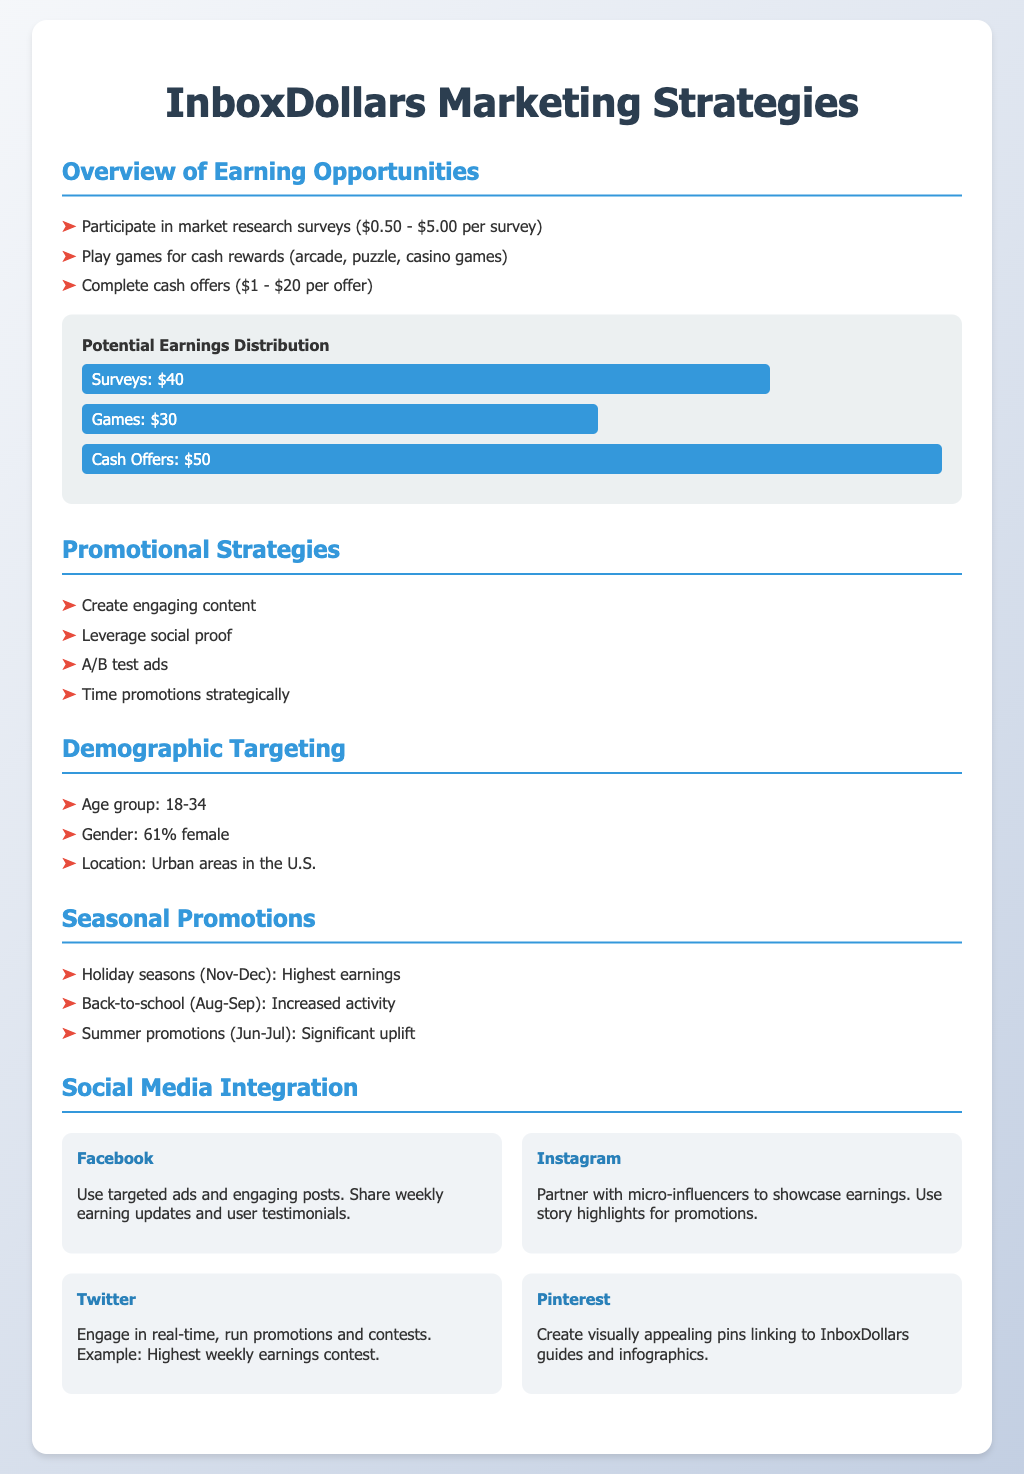What are the cash offers earnings range? The document states that earnings from cash offers range from $1 to $20 per offer.
Answer: $1 - $20 What is the age group primarily targeted in the demographic section? The demographic section identifies the age group primarily targeted as 18-34.
Answer: 18-34 How much can users earn from surveys? The document specifies that users can earn between $0.50 and $5.00 per survey.
Answer: $0.50 - $5.00 Which holiday season shows the highest earnings? The seasonal promotions section indicates that the holiday seasons (November-December) show the highest earnings.
Answer: Nov-Dec What percentage of the InboxDollars users are female? The demographic targeting information reveals that 61% of users are female.
Answer: 61% What is the potential earning distribution percentage for cash offers? The chart shows that the potential earnings distribution for cash offers is represented by 100%.
Answer: 100% Which social media platform suggests partnering with micro-influencers? Under social media integration, Instagram is suggested for partnership with micro-influencers.
Answer: Instagram What is one of the effective promotional strategies mentioned? The document lists A/B testing ads as one of the effective promotional strategies.
Answer: A/B test ads What is the optimal time for promotions according to the document? The document suggests timing promotions strategically for better results.
Answer: Time promotions strategically 